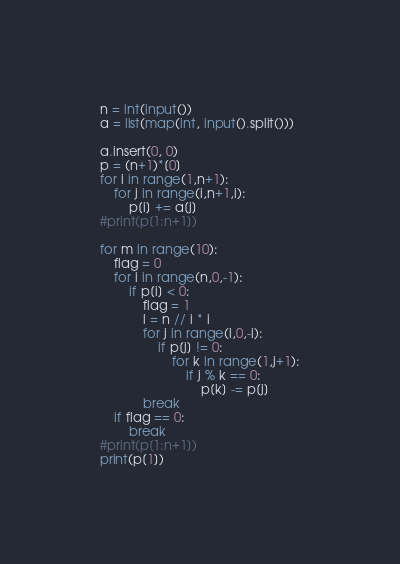<code> <loc_0><loc_0><loc_500><loc_500><_Python_>n = int(input())
a = list(map(int, input().split()))

a.insert(0, 0)
p = (n+1)*[0]
for i in range(1,n+1):
    for j in range(i,n+1,i):
        p[i] += a[j]
#print(p[1:n+1])

for m in range(10):
    flag = 0
    for i in range(n,0,-1):
        if p[i] < 0:
            flag = 1
            l = n // i * i
            for j in range(l,0,-i):
                if p[j] != 0:
                    for k in range(1,j+1):
                        if j % k == 0:
                            p[k] -= p[j]
            break
    if flag == 0:
        break
#print(p[1:n+1])
print(p[1])
</code> 